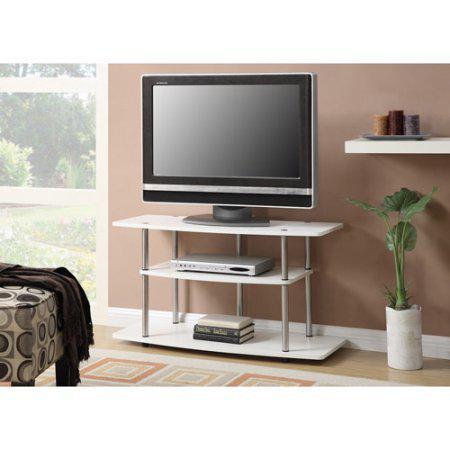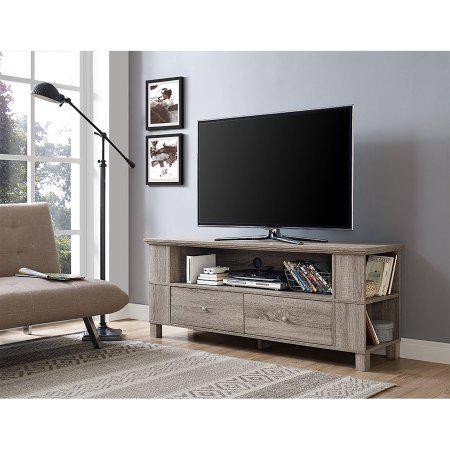The first image is the image on the left, the second image is the image on the right. Given the left and right images, does the statement "Only one of the televisions appears to be reflecting light; the other tv is completely dark." hold true? Answer yes or no. Yes. The first image is the image on the left, the second image is the image on the right. Evaluate the accuracy of this statement regarding the images: "There is a lamp near the television in the image on the right.". Is it true? Answer yes or no. Yes. 